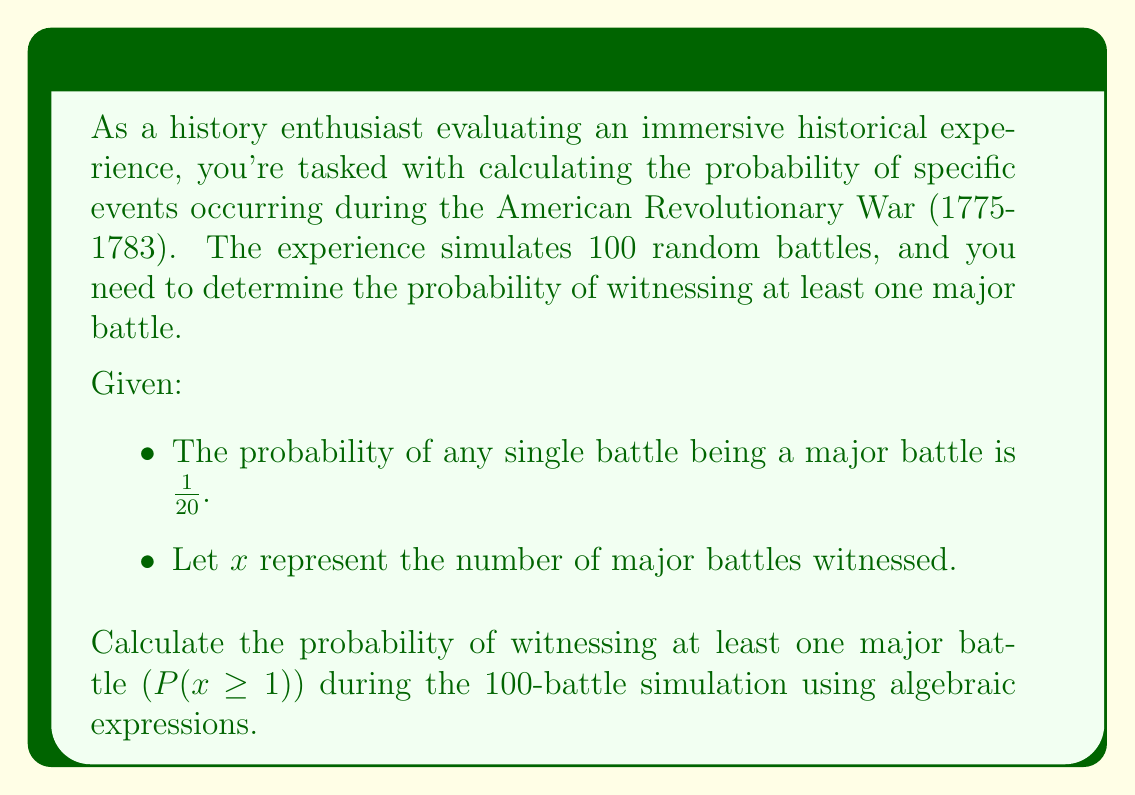Could you help me with this problem? To solve this problem, we'll use the complement method:

1) First, let's consider the probability of not witnessing any major battles $(P(x = 0))$.

2) For each individual battle, the probability of it not being a major battle is:
   $1 - \frac{1}{20} = \frac{19}{20}$

3) For all 100 battles to not be major, this needs to happen 100 times in a row. We can express this as:
   $P(x = 0) = (\frac{19}{20})^{100}$

4) Now, the probability of witnessing at least one major battle is the complement of witnessing no major battles:
   $P(x \geq 1) = 1 - P(x = 0)$

5) Substituting our expression from step 3:
   $P(x \geq 1) = 1 - (\frac{19}{20})^{100}$

6) We can simplify this using a calculator:
   $P(x \geq 1) = 1 - (0.95)^{100} \approx 0.9941$

7) Converting to a percentage:
   $0.9941 \times 100\% = 99.41\%$

Therefore, the probability of witnessing at least one major battle during the 100-battle simulation is approximately 99.41%.
Answer: $P(x \geq 1) = 1 - (\frac{19}{20})^{100} \approx 0.9941$ or 99.41% 